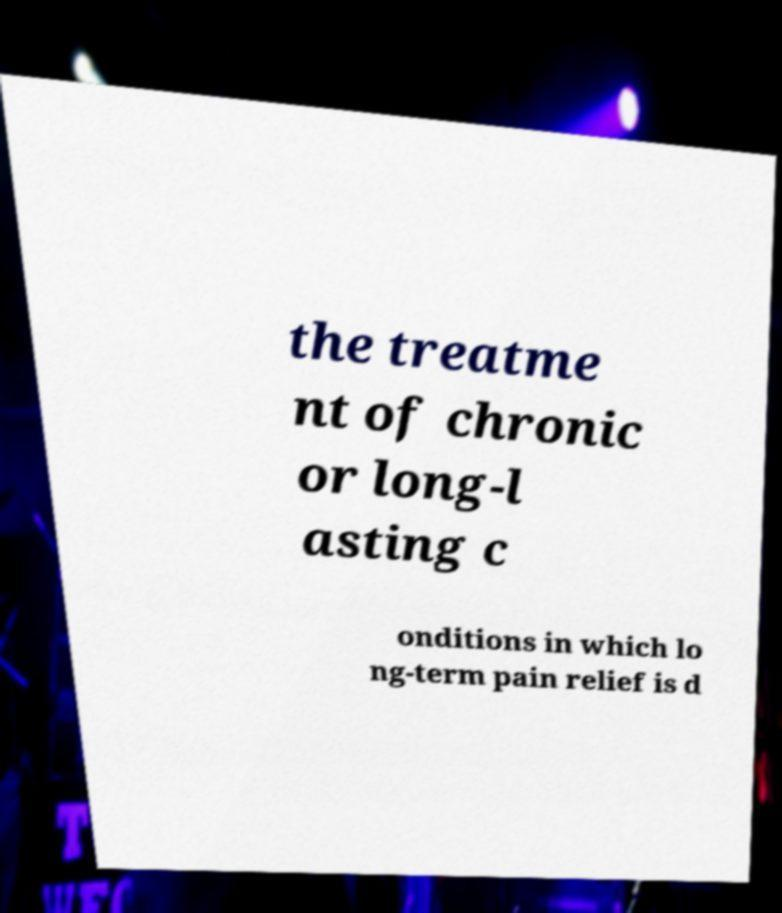Please identify and transcribe the text found in this image. the treatme nt of chronic or long-l asting c onditions in which lo ng-term pain relief is d 